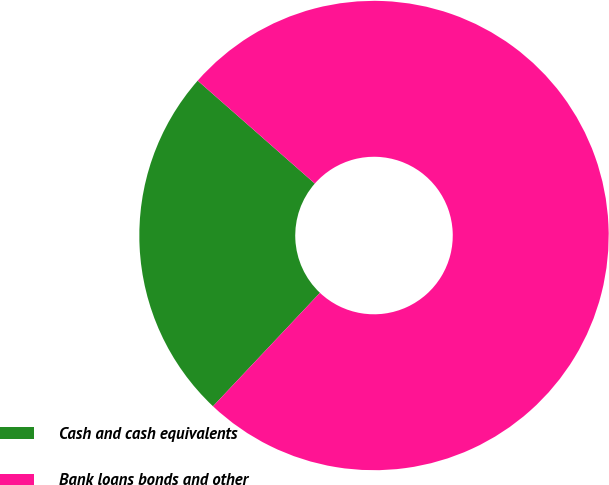Convert chart. <chart><loc_0><loc_0><loc_500><loc_500><pie_chart><fcel>Cash and cash equivalents<fcel>Bank loans bonds and other<nl><fcel>24.44%<fcel>75.56%<nl></chart> 